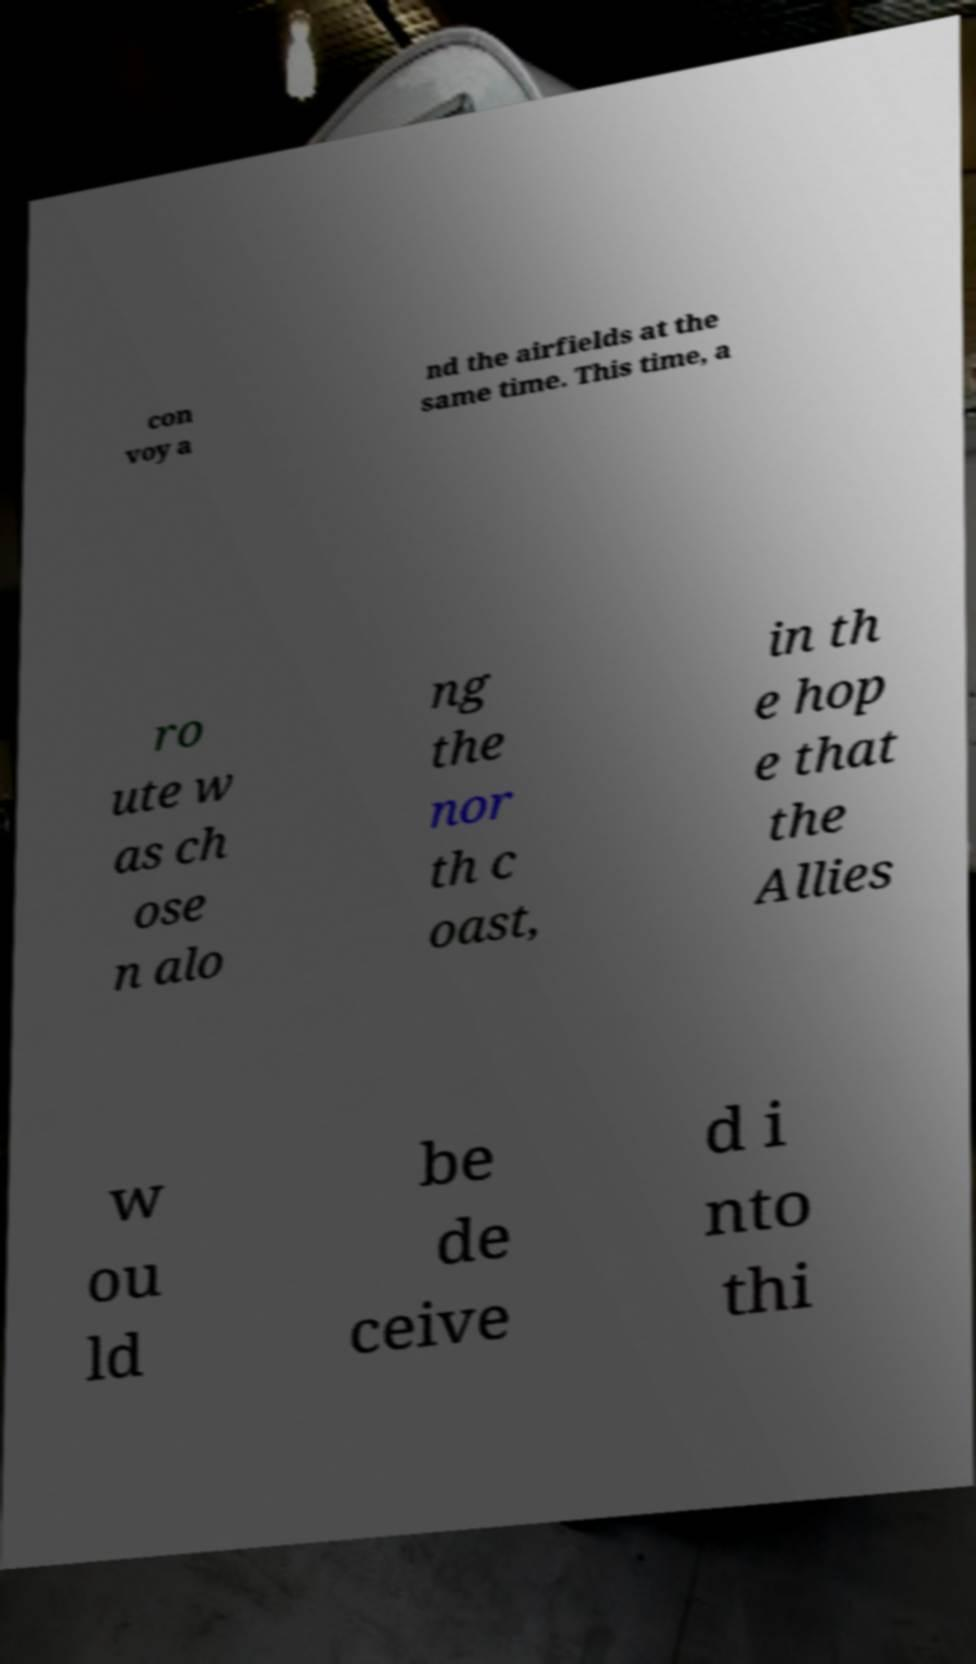What messages or text are displayed in this image? I need them in a readable, typed format. con voy a nd the airfields at the same time. This time, a ro ute w as ch ose n alo ng the nor th c oast, in th e hop e that the Allies w ou ld be de ceive d i nto thi 